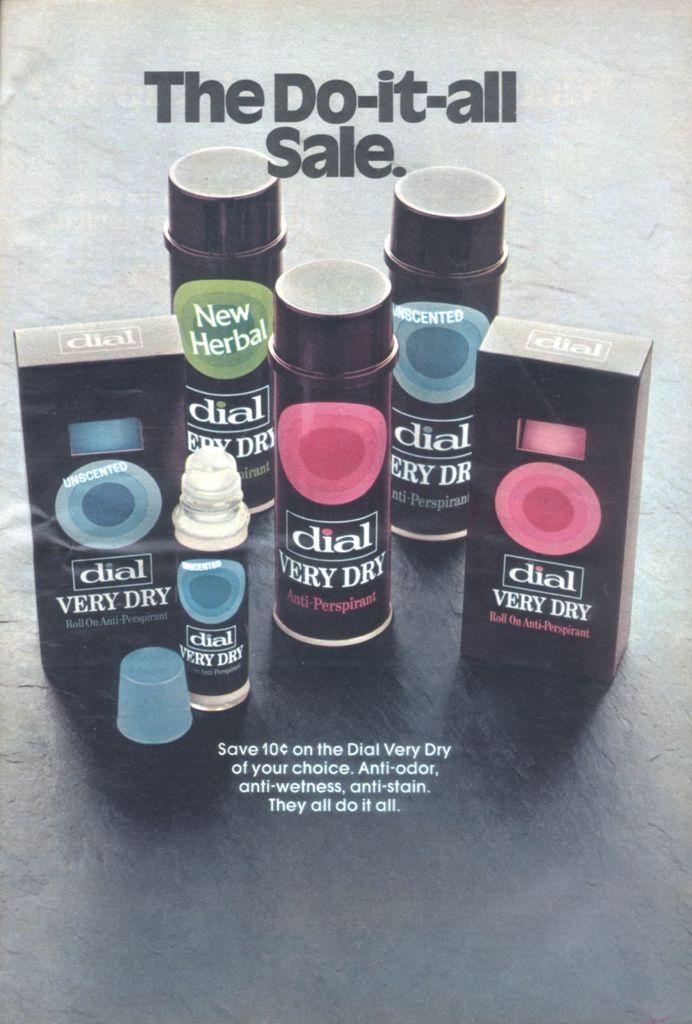This dial is all very what?
Provide a succinct answer. Dry. Is this a do it all sale?
Your response must be concise. Yes. 